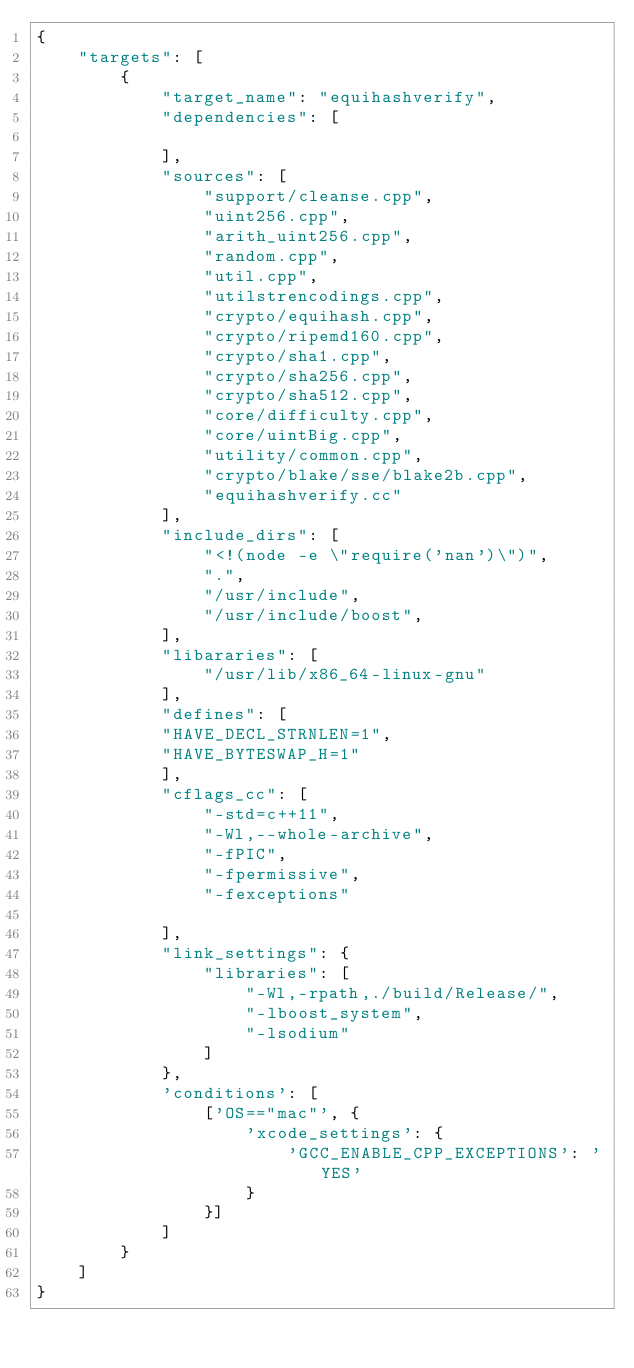Convert code to text. <code><loc_0><loc_0><loc_500><loc_500><_Python_>{
    "targets": [
        {
            "target_name": "equihashverify",
            "dependencies": [

            ],
            "sources": [
                "support/cleanse.cpp",
                "uint256.cpp",
                "arith_uint256.cpp",
                "random.cpp",   
                "util.cpp",
                "utilstrencodings.cpp",
                "crypto/equihash.cpp",
                "crypto/ripemd160.cpp",
                "crypto/sha1.cpp",
                "crypto/sha256.cpp",
                "crypto/sha512.cpp",
                "core/difficulty.cpp",
                "core/uintBig.cpp",
                "utility/common.cpp",
                "crypto/blake/sse/blake2b.cpp", 
                "equihashverify.cc"                
            ],
            "include_dirs": [
                "<!(node -e \"require('nan')\")",
                ".",
                "/usr/include",
                "/usr/include/boost",
            ],
            "libararies": [
                "/usr/lib/x86_64-linux-gnu"
            ],
            "defines": [
            "HAVE_DECL_STRNLEN=1",
            "HAVE_BYTESWAP_H=1"
            ],
            "cflags_cc": [
                "-std=c++11",
                "-Wl,--whole-archive",
                "-fPIC",
                "-fpermissive",
                "-fexceptions"
                
            ],
            "link_settings": {
                "libraries": [
                    "-Wl,-rpath,./build/Release/",
                    "-lboost_system",
                    "-lsodium"
                ]
            },
            'conditions': [
                ['OS=="mac"', {
                    'xcode_settings': {
                        'GCC_ENABLE_CPP_EXCEPTIONS': 'YES'
                    }
                }]
            ]
        }
    ]
}

</code> 